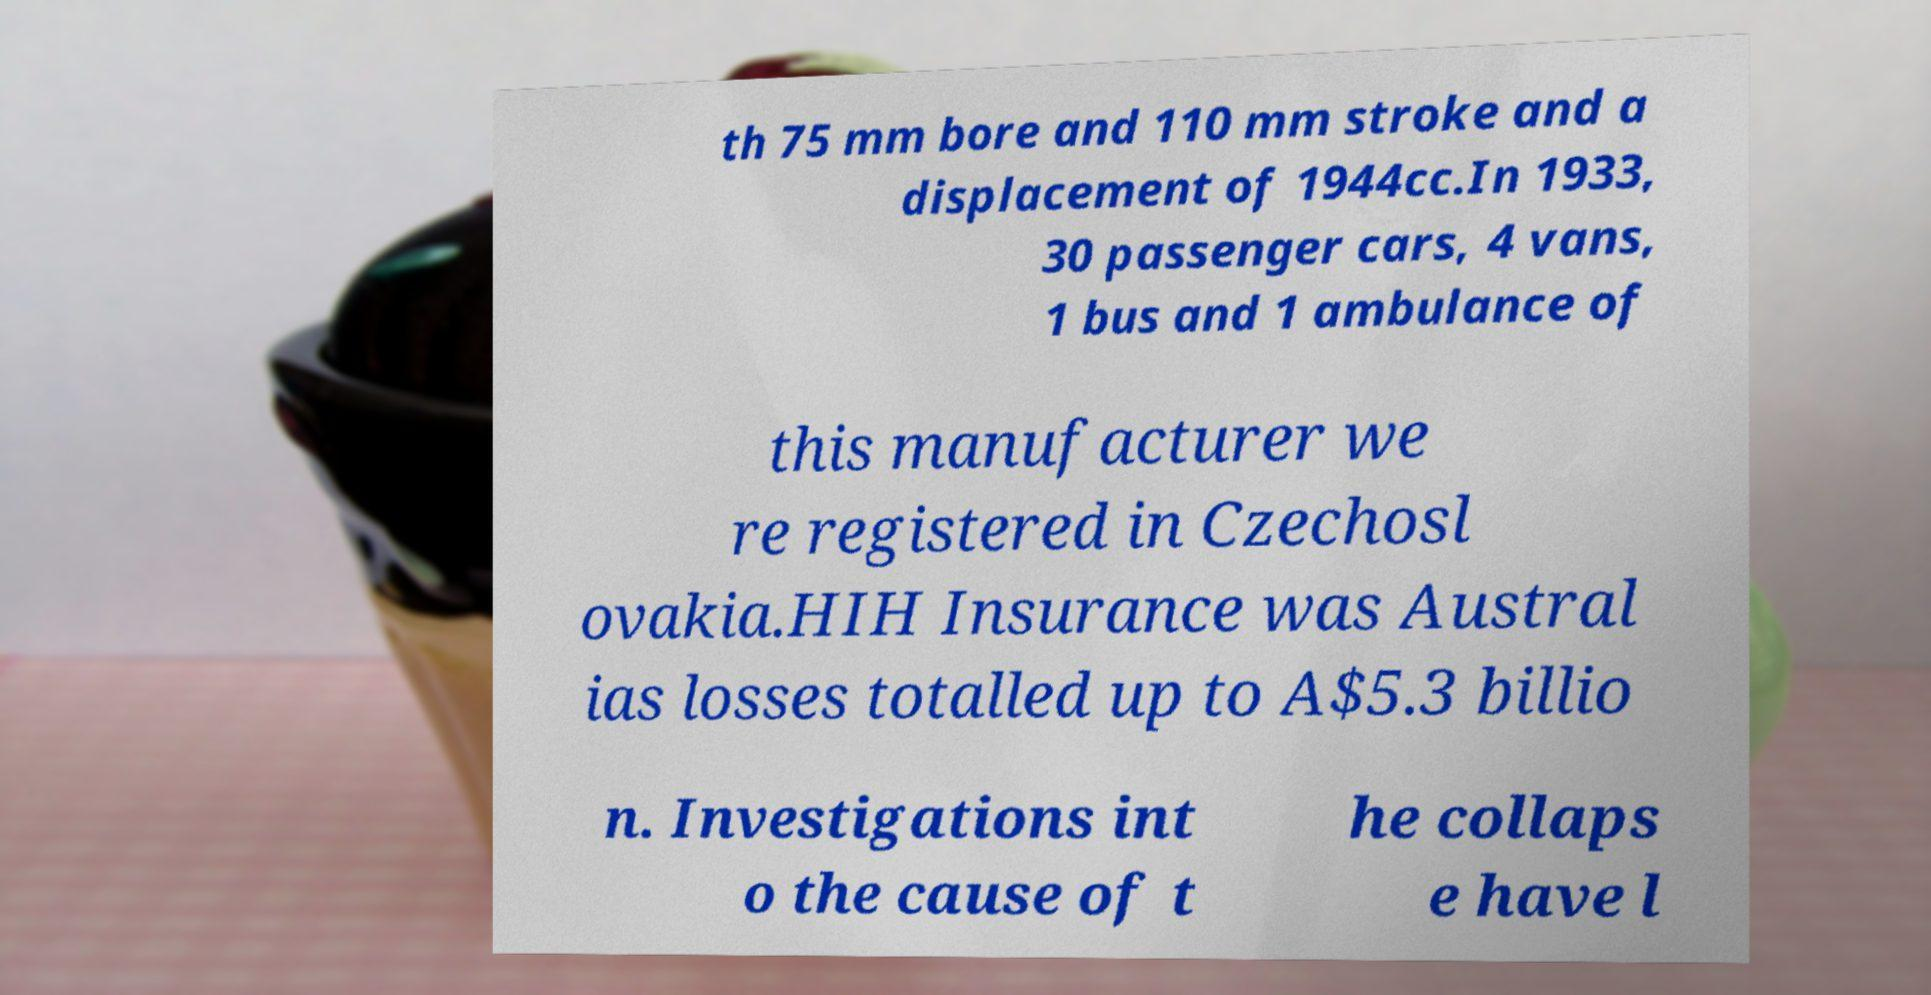Could you extract and type out the text from this image? th 75 mm bore and 110 mm stroke and a displacement of 1944cc.In 1933, 30 passenger cars, 4 vans, 1 bus and 1 ambulance of this manufacturer we re registered in Czechosl ovakia.HIH Insurance was Austral ias losses totalled up to A$5.3 billio n. Investigations int o the cause of t he collaps e have l 